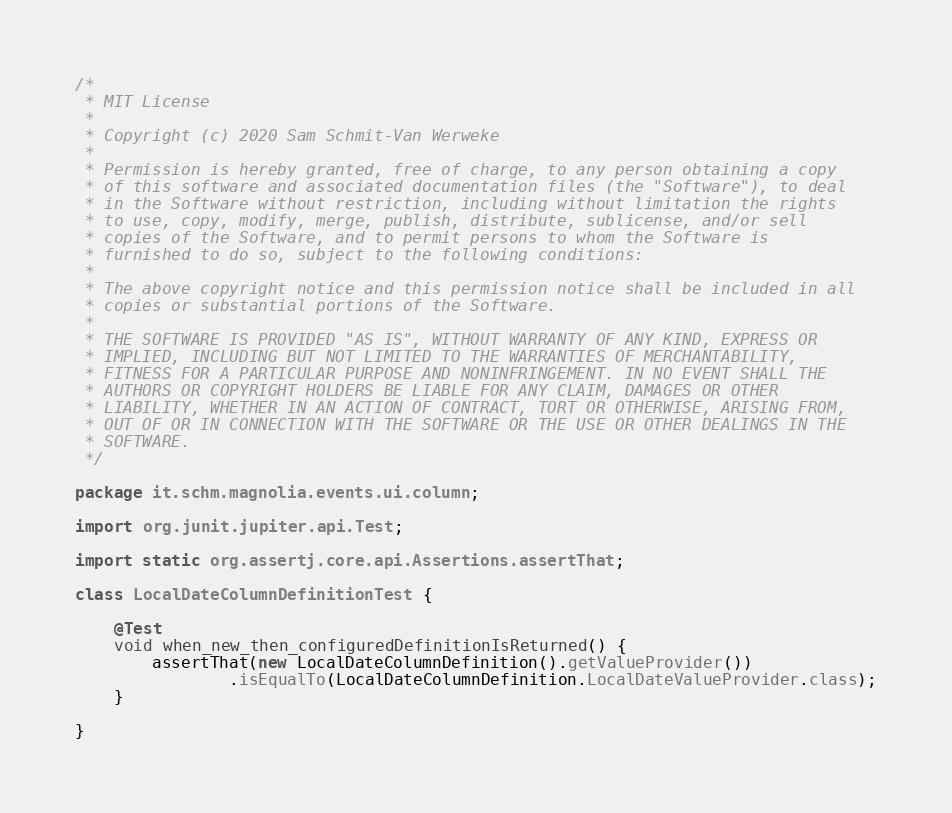Convert code to text. <code><loc_0><loc_0><loc_500><loc_500><_Java_>/*
 * MIT License
 *
 * Copyright (c) 2020 Sam Schmit-Van Werweke
 *
 * Permission is hereby granted, free of charge, to any person obtaining a copy
 * of this software and associated documentation files (the "Software"), to deal
 * in the Software without restriction, including without limitation the rights
 * to use, copy, modify, merge, publish, distribute, sublicense, and/or sell
 * copies of the Software, and to permit persons to whom the Software is
 * furnished to do so, subject to the following conditions:
 *
 * The above copyright notice and this permission notice shall be included in all
 * copies or substantial portions of the Software.
 *
 * THE SOFTWARE IS PROVIDED "AS IS", WITHOUT WARRANTY OF ANY KIND, EXPRESS OR
 * IMPLIED, INCLUDING BUT NOT LIMITED TO THE WARRANTIES OF MERCHANTABILITY,
 * FITNESS FOR A PARTICULAR PURPOSE AND NONINFRINGEMENT. IN NO EVENT SHALL THE
 * AUTHORS OR COPYRIGHT HOLDERS BE LIABLE FOR ANY CLAIM, DAMAGES OR OTHER
 * LIABILITY, WHETHER IN AN ACTION OF CONTRACT, TORT OR OTHERWISE, ARISING FROM,
 * OUT OF OR IN CONNECTION WITH THE SOFTWARE OR THE USE OR OTHER DEALINGS IN THE
 * SOFTWARE.
 */

package it.schm.magnolia.events.ui.column;

import org.junit.jupiter.api.Test;

import static org.assertj.core.api.Assertions.assertThat;

class LocalDateColumnDefinitionTest {

    @Test
    void when_new_then_configuredDefinitionIsReturned() {
        assertThat(new LocalDateColumnDefinition().getValueProvider())
                .isEqualTo(LocalDateColumnDefinition.LocalDateValueProvider.class);
    }

}
</code> 